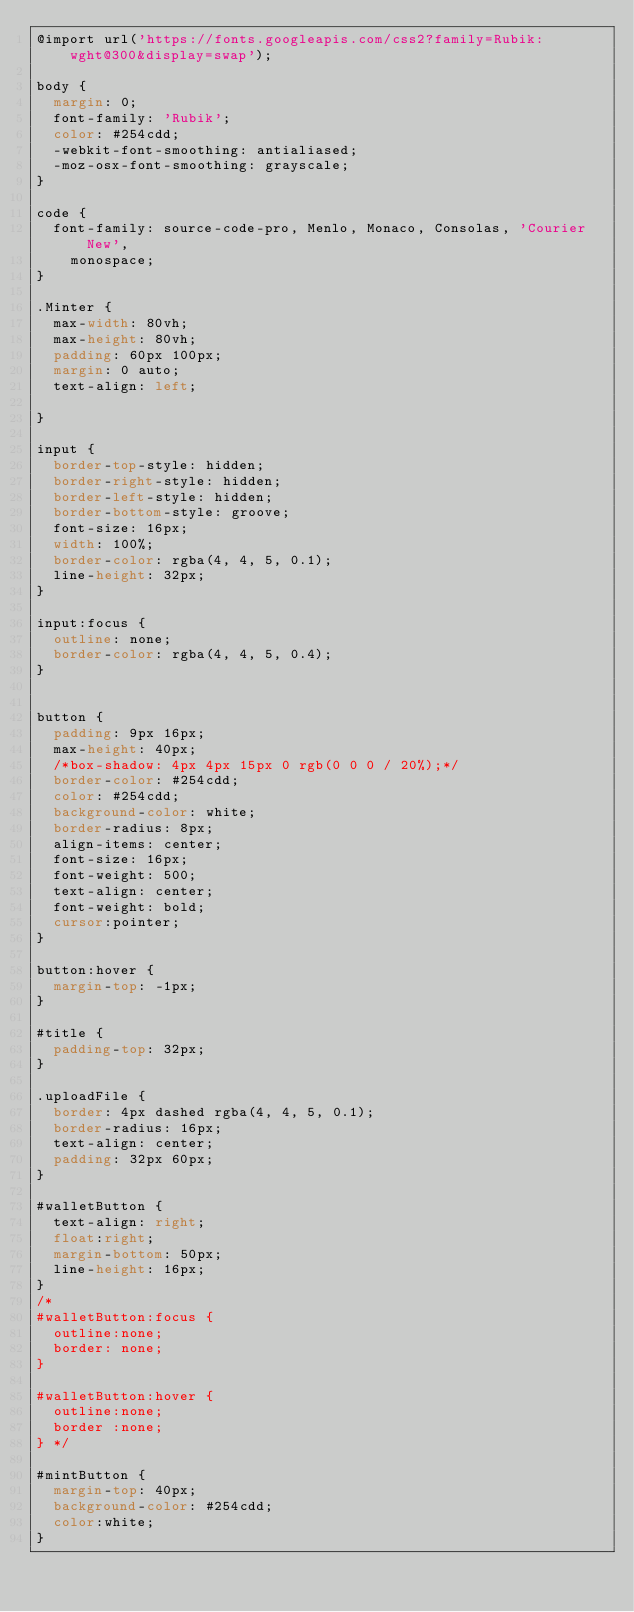<code> <loc_0><loc_0><loc_500><loc_500><_CSS_>@import url('https://fonts.googleapis.com/css2?family=Rubik:wght@300&display=swap');

body {
  margin: 0;
  font-family: 'Rubik';
  color: #254cdd;
  -webkit-font-smoothing: antialiased;
  -moz-osx-font-smoothing: grayscale;
}

code {
  font-family: source-code-pro, Menlo, Monaco, Consolas, 'Courier New',
    monospace;
}

.Minter {
  max-width: 80vh;
  max-height: 80vh;
  padding: 60px 100px;
  margin: 0 auto;
  text-align: left;

}

input {
  border-top-style: hidden;
  border-right-style: hidden;
  border-left-style: hidden;
  border-bottom-style: groove;
  font-size: 16px;
  width: 100%;
  border-color: rgba(4, 4, 5, 0.1);
  line-height: 32px;
}

input:focus {
  outline: none;
  border-color: rgba(4, 4, 5, 0.4);
}


button {
  padding: 9px 16px;
  max-height: 40px;
  /*box-shadow: 4px 4px 15px 0 rgb(0 0 0 / 20%);*/
  border-color: #254cdd;
  color: #254cdd;
  background-color: white;
  border-radius: 8px;
  align-items: center;
  font-size: 16px;
  font-weight: 500;
  text-align: center;
  font-weight: bold;
  cursor:pointer;
}

button:hover {
  margin-top: -1px;
}

#title {
  padding-top: 32px;
}

.uploadFile {
  border: 4px dashed rgba(4, 4, 5, 0.1);
  border-radius: 16px;
  text-align: center;
  padding: 32px 60px;
}

#walletButton {
  text-align: right;
  float:right;
  margin-bottom: 50px;
  line-height: 16px;
}
/*
#walletButton:focus {
  outline:none;
  border: none;
}

#walletButton:hover {
  outline:none;
  border :none;
} */

#mintButton {
  margin-top: 40px;
  background-color: #254cdd;
  color:white;
}</code> 